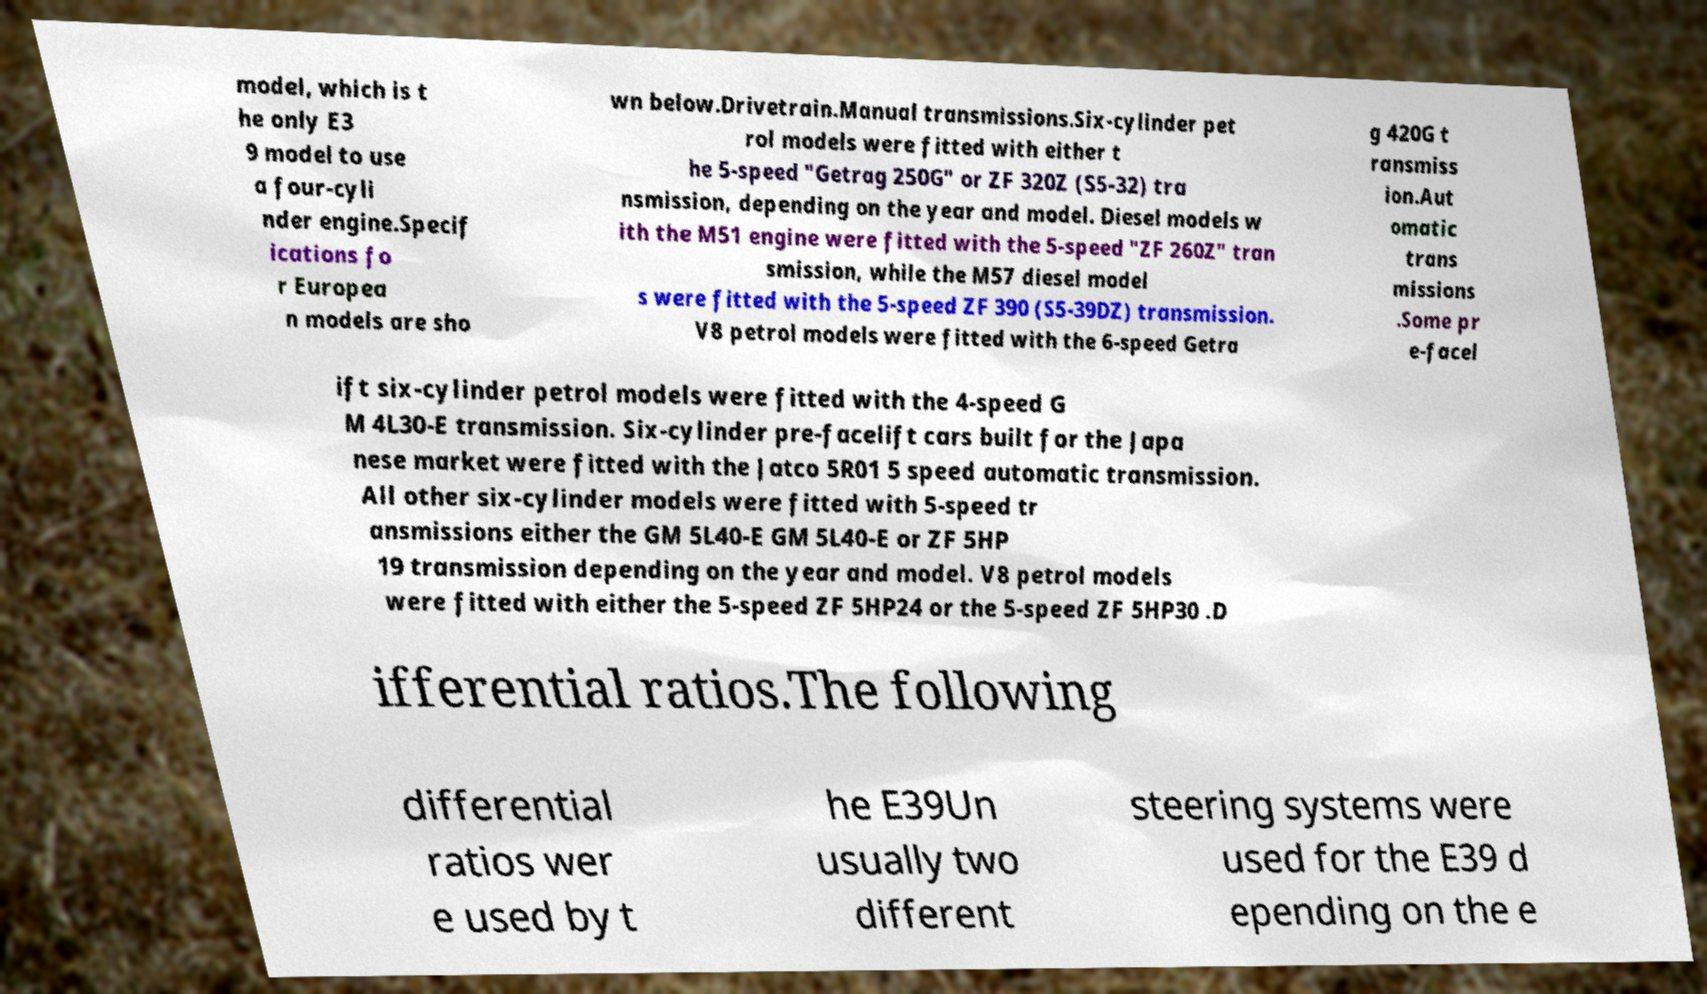Can you accurately transcribe the text from the provided image for me? model, which is t he only E3 9 model to use a four-cyli nder engine.Specif ications fo r Europea n models are sho wn below.Drivetrain.Manual transmissions.Six-cylinder pet rol models were fitted with either t he 5-speed "Getrag 250G" or ZF 320Z (S5-32) tra nsmission, depending on the year and model. Diesel models w ith the M51 engine were fitted with the 5-speed "ZF 260Z" tran smission, while the M57 diesel model s were fitted with the 5-speed ZF 390 (S5-39DZ) transmission. V8 petrol models were fitted with the 6-speed Getra g 420G t ransmiss ion.Aut omatic trans missions .Some pr e-facel ift six-cylinder petrol models were fitted with the 4-speed G M 4L30-E transmission. Six-cylinder pre-facelift cars built for the Japa nese market were fitted with the Jatco 5R01 5 speed automatic transmission. All other six-cylinder models were fitted with 5-speed tr ansmissions either the GM 5L40-E GM 5L40-E or ZF 5HP 19 transmission depending on the year and model. V8 petrol models were fitted with either the 5-speed ZF 5HP24 or the 5-speed ZF 5HP30 .D ifferential ratios.The following differential ratios wer e used by t he E39Un usually two different steering systems were used for the E39 d epending on the e 